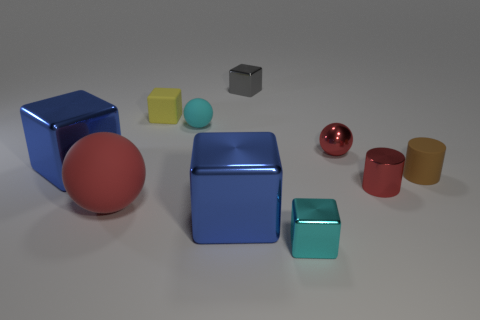Subtract all small gray blocks. How many blocks are left? 4 Subtract all yellow blocks. How many blocks are left? 4 Subtract all purple balls. How many blue blocks are left? 2 Subtract 0 brown blocks. How many objects are left? 10 Subtract all spheres. How many objects are left? 7 Subtract 2 cubes. How many cubes are left? 3 Subtract all red cylinders. Subtract all blue blocks. How many cylinders are left? 1 Subtract all small yellow metallic blocks. Subtract all blue blocks. How many objects are left? 8 Add 9 matte cubes. How many matte cubes are left? 10 Add 9 tiny brown cylinders. How many tiny brown cylinders exist? 10 